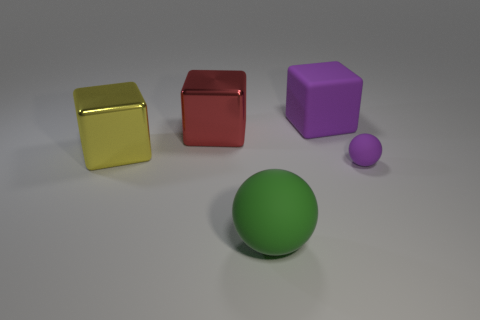There is a ball to the right of the large rubber object that is on the left side of the purple matte thing that is behind the red thing; what is its material? The ball to the right of the large rubber object appears to be made of a smooth, matte material, similar to rubber; however, without further tactile or visual details, precise material identification may vary. 